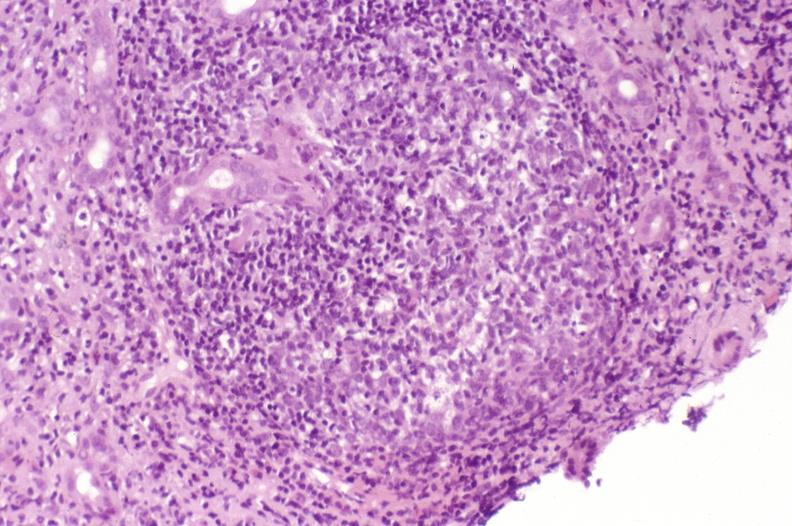s cardiovascular present?
Answer the question using a single word or phrase. No 